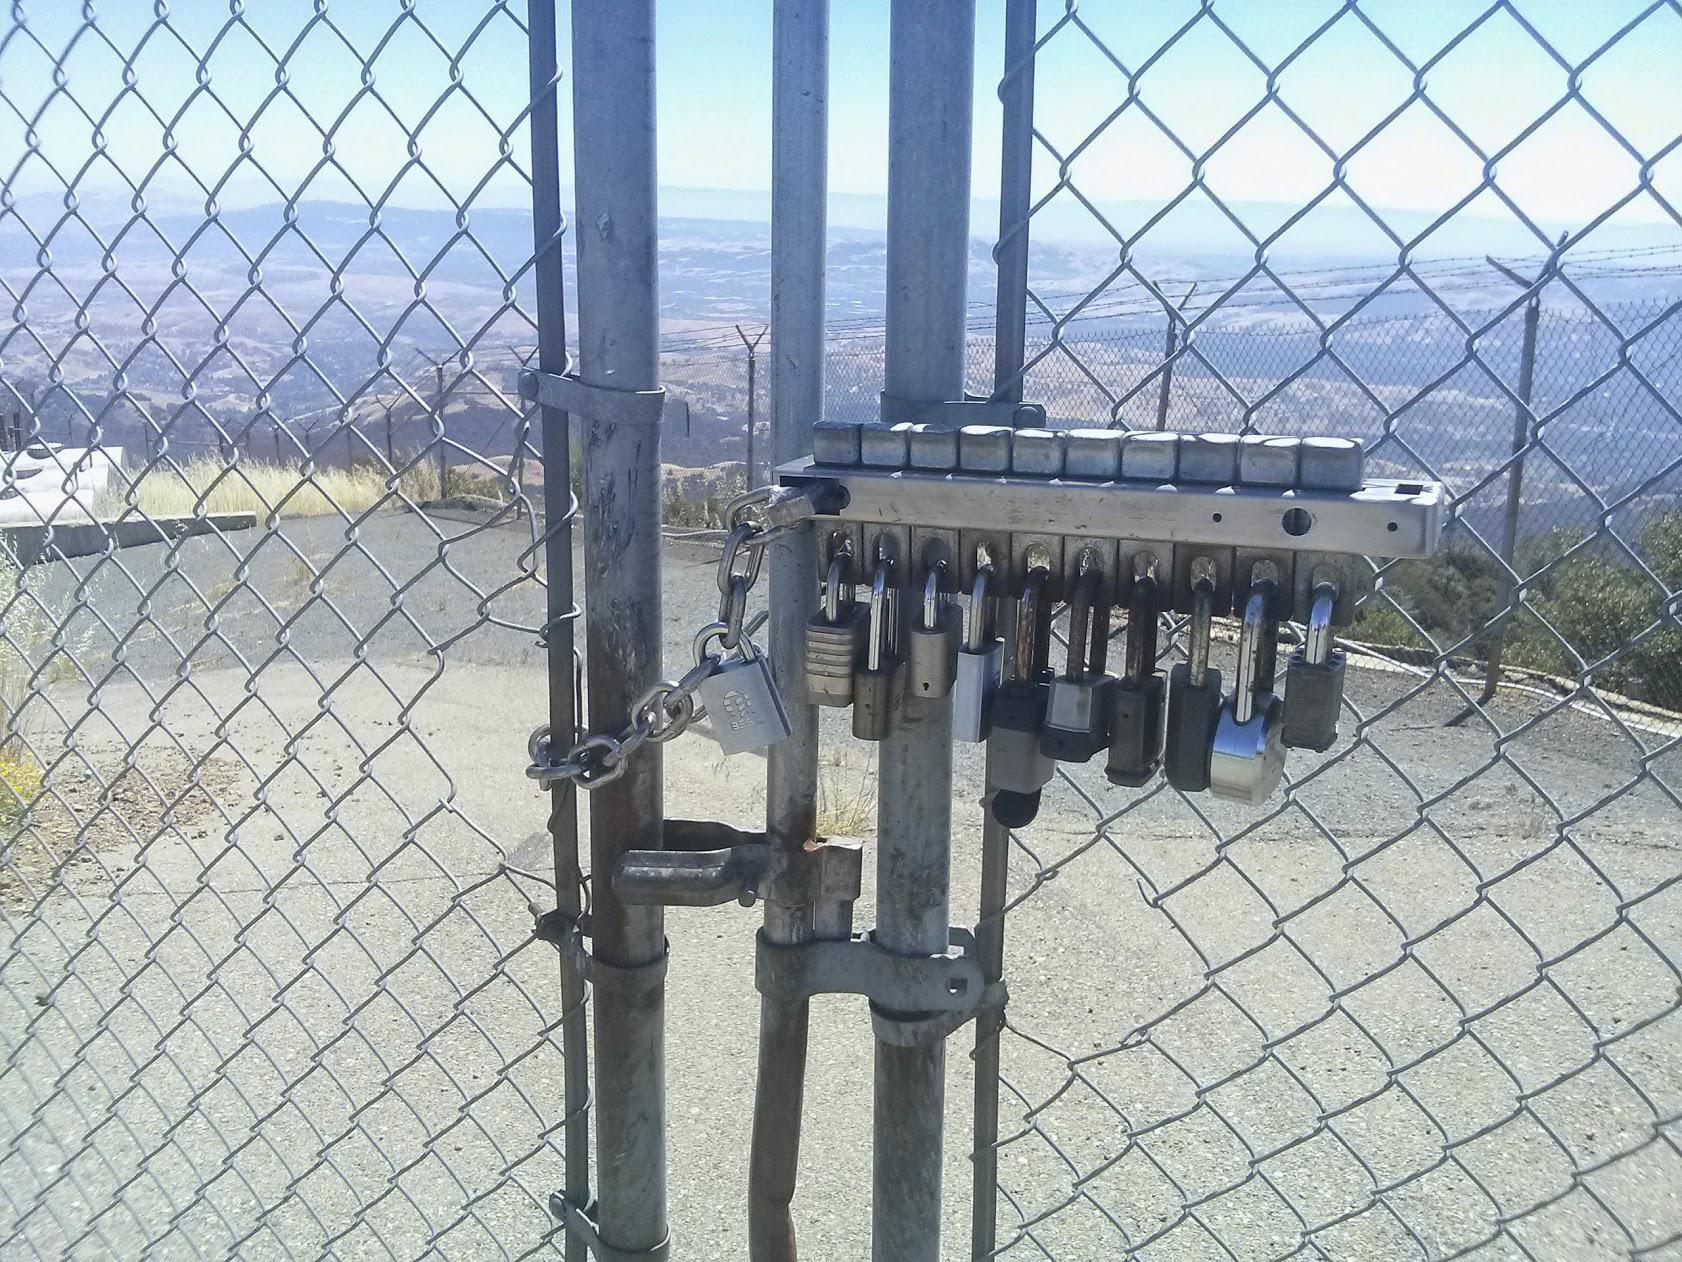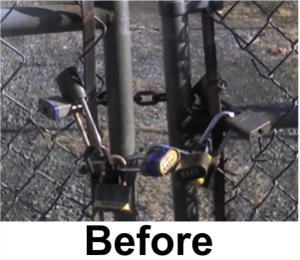The first image is the image on the left, the second image is the image on the right. For the images shown, is this caption "At least one image contains no less than six locks." true? Answer yes or no. Yes. The first image is the image on the left, the second image is the image on the right. Given the left and right images, does the statement "In one of the images, the locks are seen placed on something other than a metal fence." hold true? Answer yes or no. No. 